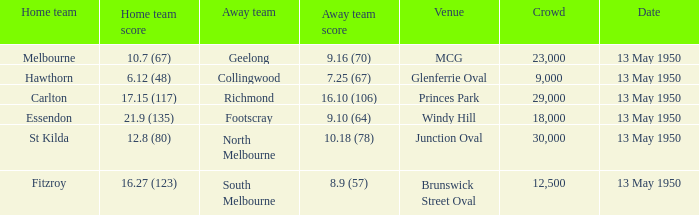What was the lowest crowd size at the Windy Hill venue? 18000.0. 